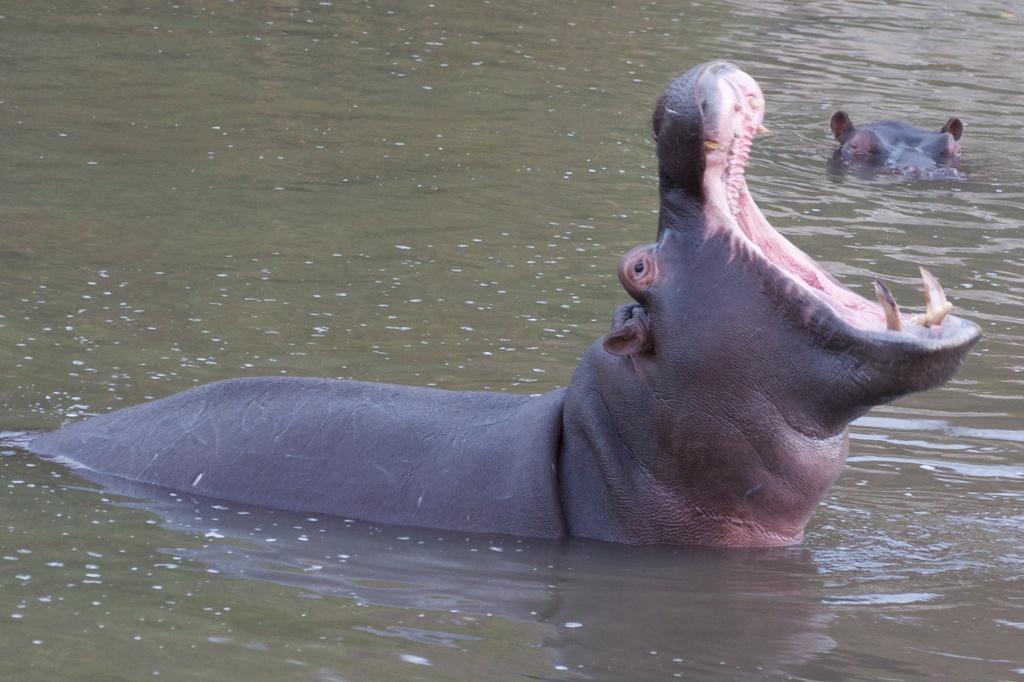In one or two sentences, can you explain what this image depicts? In this image we can see two animals in the water. 